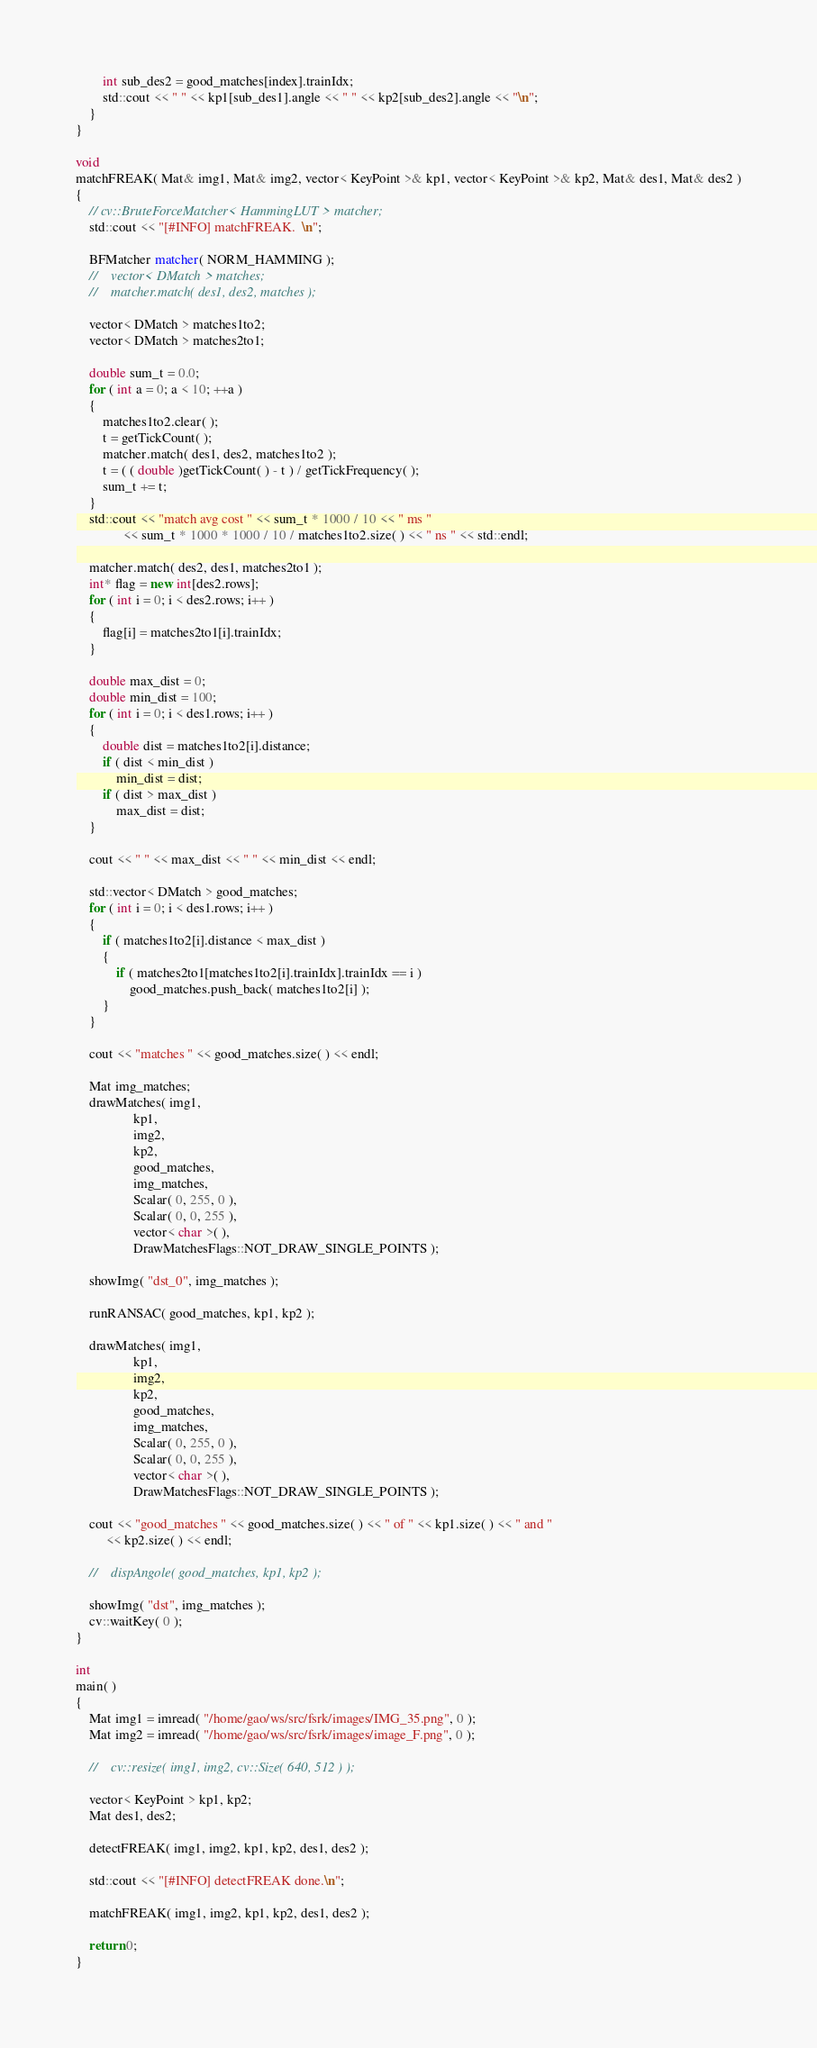Convert code to text. <code><loc_0><loc_0><loc_500><loc_500><_C++_>        int sub_des2 = good_matches[index].trainIdx;
        std::cout << " " << kp1[sub_des1].angle << " " << kp2[sub_des2].angle << "\n";
    }
}

void
matchFREAK( Mat& img1, Mat& img2, vector< KeyPoint >& kp1, vector< KeyPoint >& kp2, Mat& des1, Mat& des2 )
{
    // cv::BruteForceMatcher< HammingLUT > matcher;
    std::cout << "[#INFO] matchFREAK.  \n";

    BFMatcher matcher( NORM_HAMMING );
    //    vector< DMatch > matches;
    //    matcher.match( des1, des2, matches );

    vector< DMatch > matches1to2;
    vector< DMatch > matches2to1;

    double sum_t = 0.0;
    for ( int a = 0; a < 10; ++a )
    {
        matches1to2.clear( );
        t = getTickCount( );
        matcher.match( des1, des2, matches1to2 );
        t = ( ( double )getTickCount( ) - t ) / getTickFrequency( );
        sum_t += t;
    }
    std::cout << "match avg cost " << sum_t * 1000 / 10 << " ms "
              << sum_t * 1000 * 1000 / 10 / matches1to2.size( ) << " ns " << std::endl;

    matcher.match( des2, des1, matches2to1 );
    int* flag = new int[des2.rows];
    for ( int i = 0; i < des2.rows; i++ )
    {
        flag[i] = matches2to1[i].trainIdx;
    }

    double max_dist = 0;
    double min_dist = 100;
    for ( int i = 0; i < des1.rows; i++ )
    {
        double dist = matches1to2[i].distance;
        if ( dist < min_dist )
            min_dist = dist;
        if ( dist > max_dist )
            max_dist = dist;
    }

    cout << " " << max_dist << " " << min_dist << endl;

    std::vector< DMatch > good_matches;
    for ( int i = 0; i < des1.rows; i++ )
    {
        if ( matches1to2[i].distance < max_dist )
        {
            if ( matches2to1[matches1to2[i].trainIdx].trainIdx == i )
                good_matches.push_back( matches1to2[i] );
        }
    }

    cout << "matches " << good_matches.size( ) << endl;

    Mat img_matches;
    drawMatches( img1,
                 kp1,
                 img2,
                 kp2,
                 good_matches,
                 img_matches,
                 Scalar( 0, 255, 0 ),
                 Scalar( 0, 0, 255 ),
                 vector< char >( ),
                 DrawMatchesFlags::NOT_DRAW_SINGLE_POINTS );

    showImg( "dst_0", img_matches );

    runRANSAC( good_matches, kp1, kp2 );

    drawMatches( img1,
                 kp1,
                 img2,
                 kp2,
                 good_matches,
                 img_matches,
                 Scalar( 0, 255, 0 ),
                 Scalar( 0, 0, 255 ),
                 vector< char >( ),
                 DrawMatchesFlags::NOT_DRAW_SINGLE_POINTS );

    cout << "good_matches " << good_matches.size( ) << " of " << kp1.size( ) << " and "
         << kp2.size( ) << endl;

    //    dispAngole( good_matches, kp1, kp2 );

    showImg( "dst", img_matches );
    cv::waitKey( 0 );
}

int
main( )
{
    Mat img1 = imread( "/home/gao/ws/src/fsrk/images/IMG_35.png", 0 );
    Mat img2 = imread( "/home/gao/ws/src/fsrk/images/image_F.png", 0 );

    //    cv::resize( img1, img2, cv::Size( 640, 512 ) );

    vector< KeyPoint > kp1, kp2;
    Mat des1, des2;

    detectFREAK( img1, img2, kp1, kp2, des1, des2 );

    std::cout << "[#INFO] detectFREAK done.\n";

    matchFREAK( img1, img2, kp1, kp2, des1, des2 );

    return 0;
}
</code> 